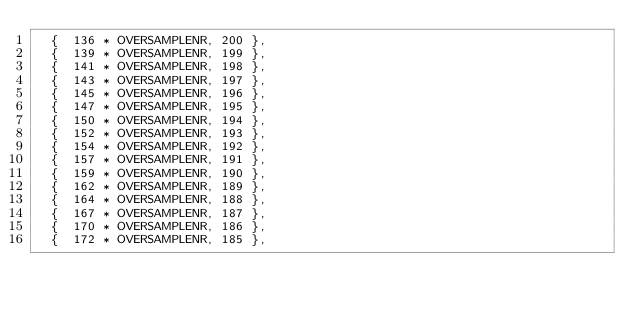<code> <loc_0><loc_0><loc_500><loc_500><_C_>  {  136 * OVERSAMPLENR, 200 },
  {  139 * OVERSAMPLENR, 199 },
  {  141 * OVERSAMPLENR, 198 },
  {  143 * OVERSAMPLENR, 197 },
  {  145 * OVERSAMPLENR, 196 },
  {  147 * OVERSAMPLENR, 195 },
  {  150 * OVERSAMPLENR, 194 },
  {  152 * OVERSAMPLENR, 193 },
  {  154 * OVERSAMPLENR, 192 },
  {  157 * OVERSAMPLENR, 191 },
  {  159 * OVERSAMPLENR, 190 },
  {  162 * OVERSAMPLENR, 189 },
  {  164 * OVERSAMPLENR, 188 },
  {  167 * OVERSAMPLENR, 187 },
  {  170 * OVERSAMPLENR, 186 },
  {  172 * OVERSAMPLENR, 185 },</code> 